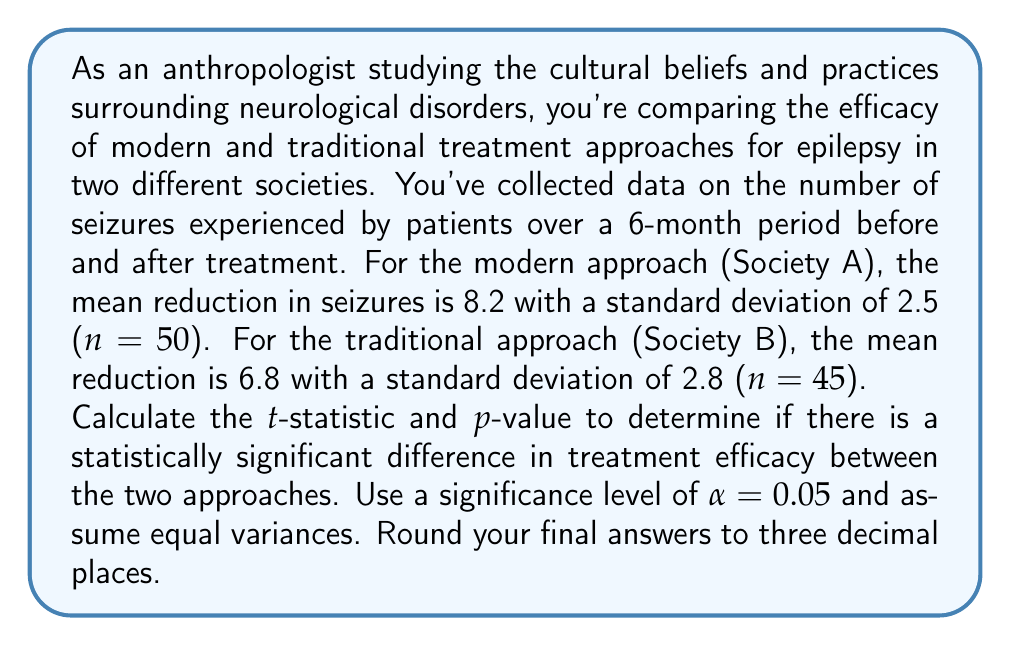Give your solution to this math problem. To determine if there is a statistically significant difference between the two treatment approaches, we'll use an independent two-sample t-test. We'll follow these steps:

1. Calculate the pooled standard deviation
2. Calculate the t-statistic
3. Determine the degrees of freedom
4. Calculate the p-value

Step 1: Calculate the pooled standard deviation

The formula for pooled standard deviation is:

$$ s_p = \sqrt{\frac{(n_1 - 1)s_1^2 + (n_2 - 1)s_2^2}{n_1 + n_2 - 2}} $$

Where:
$n_1 = 50$, $s_1 = 2.5$ (Society A)
$n_2 = 45$, $s_2 = 2.8$ (Society B)

$$ s_p = \sqrt{\frac{(50 - 1)(2.5)^2 + (45 - 1)(2.8)^2}{50 + 45 - 2}} $$
$$ s_p = \sqrt{\frac{306.25 + 344.96}{93}} = \sqrt{7.00226} = 2.646 $$

Step 2: Calculate the t-statistic

The formula for the t-statistic is:

$$ t = \frac{\bar{x}_1 - \bar{x}_2}{s_p \sqrt{\frac{1}{n_1} + \frac{1}{n_2}}} $$

Where:
$\bar{x}_1 = 8.2$ (Society A mean)
$\bar{x}_2 = 6.8$ (Society B mean)

$$ t = \frac{8.2 - 6.8}{2.646 \sqrt{\frac{1}{50} + \frac{1}{45}}} $$
$$ t = \frac{1.4}{2.646 \sqrt{0.04222}} = \frac{1.4}{0.5438} = 2.575 $$

Step 3: Determine the degrees of freedom

$df = n_1 + n_2 - 2 = 50 + 45 - 2 = 93$

Step 4: Calculate the p-value

Using a t-distribution table or calculator with 93 degrees of freedom and a t-statistic of 2.575, we find the p-value:

$p = 0.0116$ (two-tailed)

Since $p < 0.05$, we reject the null hypothesis and conclude that there is a statistically significant difference in treatment efficacy between the modern and traditional approaches.
Answer: t-statistic: 2.575
p-value: 0.012 